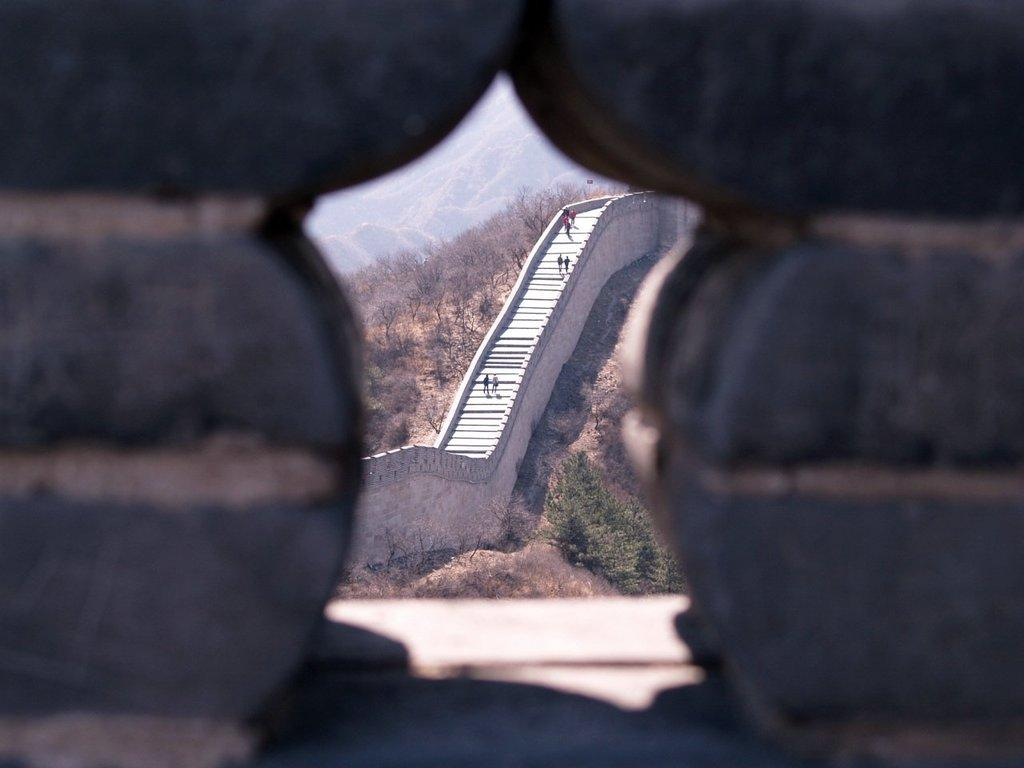What is the main feature of the image? There is a hole in the image. What can be seen through the hole? A long staircase is visible through the hole. Are there any people in the image? Yes, people are standing on the staircase. What is the surrounding environment like? The staircase is surrounded by bushes and trees. What can be seen in the distance? Mountains are visible in the background. What type of statement is being made by the powder in the image? There is no powder present in the image, so no statement can be made by it. 